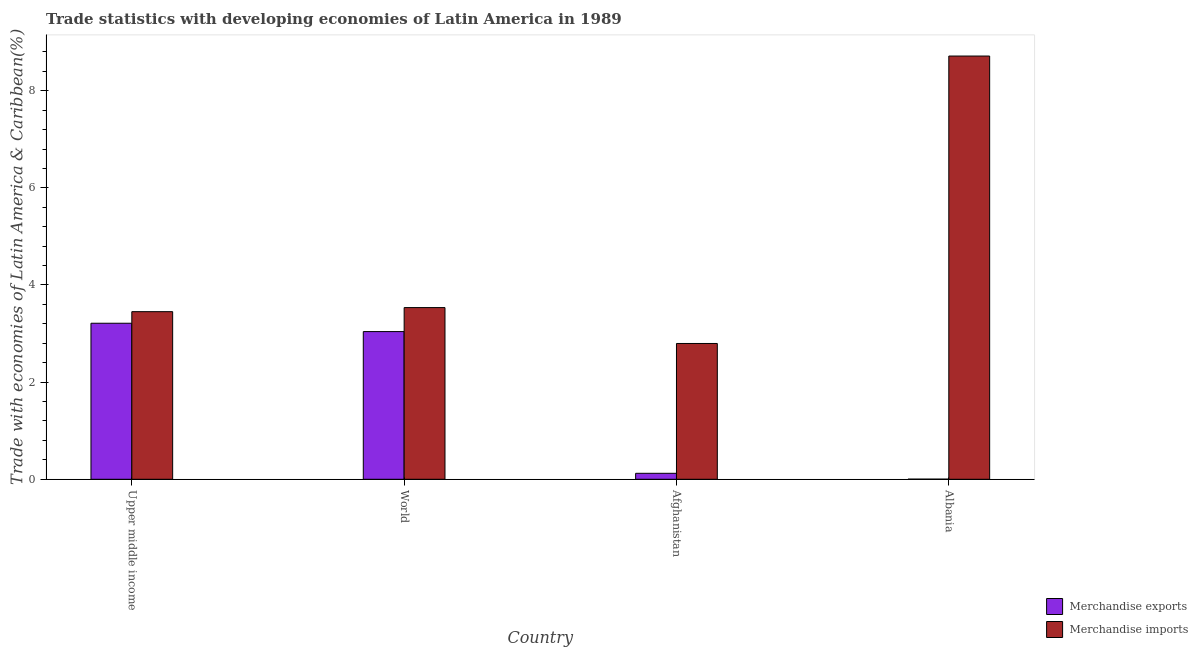How many different coloured bars are there?
Provide a succinct answer. 2. Are the number of bars on each tick of the X-axis equal?
Offer a very short reply. Yes. How many bars are there on the 2nd tick from the left?
Your answer should be compact. 2. What is the label of the 3rd group of bars from the left?
Offer a very short reply. Afghanistan. In how many cases, is the number of bars for a given country not equal to the number of legend labels?
Provide a short and direct response. 0. What is the merchandise exports in World?
Provide a succinct answer. 3.04. Across all countries, what is the maximum merchandise exports?
Your answer should be very brief. 3.21. Across all countries, what is the minimum merchandise imports?
Provide a short and direct response. 2.8. In which country was the merchandise imports maximum?
Your answer should be compact. Albania. In which country was the merchandise imports minimum?
Your answer should be compact. Afghanistan. What is the total merchandise exports in the graph?
Your answer should be compact. 6.38. What is the difference between the merchandise imports in Albania and that in Upper middle income?
Make the answer very short. 5.26. What is the difference between the merchandise imports in Albania and the merchandise exports in World?
Your answer should be compact. 5.67. What is the average merchandise exports per country?
Provide a short and direct response. 1.59. What is the difference between the merchandise imports and merchandise exports in Albania?
Your response must be concise. 8.71. In how many countries, is the merchandise imports greater than 3.6 %?
Keep it short and to the point. 1. What is the ratio of the merchandise imports in Afghanistan to that in World?
Your answer should be very brief. 0.79. What is the difference between the highest and the second highest merchandise exports?
Your answer should be compact. 0.17. What is the difference between the highest and the lowest merchandise imports?
Provide a short and direct response. 5.92. What does the 1st bar from the left in Upper middle income represents?
Offer a terse response. Merchandise exports. What does the 2nd bar from the right in World represents?
Provide a succinct answer. Merchandise exports. Are all the bars in the graph horizontal?
Keep it short and to the point. No. How many countries are there in the graph?
Offer a terse response. 4. Does the graph contain any zero values?
Provide a short and direct response. No. Where does the legend appear in the graph?
Your answer should be very brief. Bottom right. How are the legend labels stacked?
Ensure brevity in your answer.  Vertical. What is the title of the graph?
Offer a terse response. Trade statistics with developing economies of Latin America in 1989. Does "State government" appear as one of the legend labels in the graph?
Ensure brevity in your answer.  No. What is the label or title of the Y-axis?
Your response must be concise. Trade with economies of Latin America & Caribbean(%). What is the Trade with economies of Latin America & Caribbean(%) of Merchandise exports in Upper middle income?
Your response must be concise. 3.21. What is the Trade with economies of Latin America & Caribbean(%) of Merchandise imports in Upper middle income?
Provide a succinct answer. 3.45. What is the Trade with economies of Latin America & Caribbean(%) in Merchandise exports in World?
Give a very brief answer. 3.04. What is the Trade with economies of Latin America & Caribbean(%) in Merchandise imports in World?
Provide a succinct answer. 3.53. What is the Trade with economies of Latin America & Caribbean(%) of Merchandise exports in Afghanistan?
Make the answer very short. 0.12. What is the Trade with economies of Latin America & Caribbean(%) of Merchandise imports in Afghanistan?
Give a very brief answer. 2.8. What is the Trade with economies of Latin America & Caribbean(%) of Merchandise exports in Albania?
Your answer should be very brief. 0. What is the Trade with economies of Latin America & Caribbean(%) of Merchandise imports in Albania?
Provide a succinct answer. 8.71. Across all countries, what is the maximum Trade with economies of Latin America & Caribbean(%) of Merchandise exports?
Your answer should be compact. 3.21. Across all countries, what is the maximum Trade with economies of Latin America & Caribbean(%) in Merchandise imports?
Make the answer very short. 8.71. Across all countries, what is the minimum Trade with economies of Latin America & Caribbean(%) in Merchandise exports?
Ensure brevity in your answer.  0. Across all countries, what is the minimum Trade with economies of Latin America & Caribbean(%) in Merchandise imports?
Your answer should be compact. 2.8. What is the total Trade with economies of Latin America & Caribbean(%) of Merchandise exports in the graph?
Offer a very short reply. 6.38. What is the total Trade with economies of Latin America & Caribbean(%) in Merchandise imports in the graph?
Offer a very short reply. 18.5. What is the difference between the Trade with economies of Latin America & Caribbean(%) of Merchandise exports in Upper middle income and that in World?
Offer a terse response. 0.17. What is the difference between the Trade with economies of Latin America & Caribbean(%) in Merchandise imports in Upper middle income and that in World?
Your response must be concise. -0.08. What is the difference between the Trade with economies of Latin America & Caribbean(%) of Merchandise exports in Upper middle income and that in Afghanistan?
Provide a succinct answer. 3.09. What is the difference between the Trade with economies of Latin America & Caribbean(%) in Merchandise imports in Upper middle income and that in Afghanistan?
Ensure brevity in your answer.  0.66. What is the difference between the Trade with economies of Latin America & Caribbean(%) of Merchandise exports in Upper middle income and that in Albania?
Keep it short and to the point. 3.21. What is the difference between the Trade with economies of Latin America & Caribbean(%) in Merchandise imports in Upper middle income and that in Albania?
Make the answer very short. -5.26. What is the difference between the Trade with economies of Latin America & Caribbean(%) of Merchandise exports in World and that in Afghanistan?
Offer a very short reply. 2.92. What is the difference between the Trade with economies of Latin America & Caribbean(%) of Merchandise imports in World and that in Afghanistan?
Give a very brief answer. 0.74. What is the difference between the Trade with economies of Latin America & Caribbean(%) of Merchandise exports in World and that in Albania?
Your response must be concise. 3.04. What is the difference between the Trade with economies of Latin America & Caribbean(%) of Merchandise imports in World and that in Albania?
Provide a short and direct response. -5.18. What is the difference between the Trade with economies of Latin America & Caribbean(%) of Merchandise exports in Afghanistan and that in Albania?
Provide a succinct answer. 0.12. What is the difference between the Trade with economies of Latin America & Caribbean(%) of Merchandise imports in Afghanistan and that in Albania?
Make the answer very short. -5.92. What is the difference between the Trade with economies of Latin America & Caribbean(%) of Merchandise exports in Upper middle income and the Trade with economies of Latin America & Caribbean(%) of Merchandise imports in World?
Keep it short and to the point. -0.32. What is the difference between the Trade with economies of Latin America & Caribbean(%) in Merchandise exports in Upper middle income and the Trade with economies of Latin America & Caribbean(%) in Merchandise imports in Afghanistan?
Ensure brevity in your answer.  0.42. What is the difference between the Trade with economies of Latin America & Caribbean(%) in Merchandise exports in Upper middle income and the Trade with economies of Latin America & Caribbean(%) in Merchandise imports in Albania?
Your response must be concise. -5.5. What is the difference between the Trade with economies of Latin America & Caribbean(%) of Merchandise exports in World and the Trade with economies of Latin America & Caribbean(%) of Merchandise imports in Afghanistan?
Keep it short and to the point. 0.24. What is the difference between the Trade with economies of Latin America & Caribbean(%) in Merchandise exports in World and the Trade with economies of Latin America & Caribbean(%) in Merchandise imports in Albania?
Give a very brief answer. -5.67. What is the difference between the Trade with economies of Latin America & Caribbean(%) in Merchandise exports in Afghanistan and the Trade with economies of Latin America & Caribbean(%) in Merchandise imports in Albania?
Your answer should be very brief. -8.59. What is the average Trade with economies of Latin America & Caribbean(%) in Merchandise exports per country?
Ensure brevity in your answer.  1.59. What is the average Trade with economies of Latin America & Caribbean(%) in Merchandise imports per country?
Provide a short and direct response. 4.62. What is the difference between the Trade with economies of Latin America & Caribbean(%) of Merchandise exports and Trade with economies of Latin America & Caribbean(%) of Merchandise imports in Upper middle income?
Your answer should be very brief. -0.24. What is the difference between the Trade with economies of Latin America & Caribbean(%) in Merchandise exports and Trade with economies of Latin America & Caribbean(%) in Merchandise imports in World?
Provide a short and direct response. -0.49. What is the difference between the Trade with economies of Latin America & Caribbean(%) of Merchandise exports and Trade with economies of Latin America & Caribbean(%) of Merchandise imports in Afghanistan?
Provide a short and direct response. -2.67. What is the difference between the Trade with economies of Latin America & Caribbean(%) of Merchandise exports and Trade with economies of Latin America & Caribbean(%) of Merchandise imports in Albania?
Provide a succinct answer. -8.71. What is the ratio of the Trade with economies of Latin America & Caribbean(%) in Merchandise exports in Upper middle income to that in World?
Offer a very short reply. 1.06. What is the ratio of the Trade with economies of Latin America & Caribbean(%) of Merchandise imports in Upper middle income to that in World?
Offer a terse response. 0.98. What is the ratio of the Trade with economies of Latin America & Caribbean(%) of Merchandise exports in Upper middle income to that in Afghanistan?
Offer a terse response. 26.12. What is the ratio of the Trade with economies of Latin America & Caribbean(%) of Merchandise imports in Upper middle income to that in Afghanistan?
Your answer should be very brief. 1.23. What is the ratio of the Trade with economies of Latin America & Caribbean(%) in Merchandise exports in Upper middle income to that in Albania?
Offer a very short reply. 1240.08. What is the ratio of the Trade with economies of Latin America & Caribbean(%) of Merchandise imports in Upper middle income to that in Albania?
Your answer should be very brief. 0.4. What is the ratio of the Trade with economies of Latin America & Caribbean(%) in Merchandise exports in World to that in Afghanistan?
Offer a very short reply. 24.72. What is the ratio of the Trade with economies of Latin America & Caribbean(%) of Merchandise imports in World to that in Afghanistan?
Make the answer very short. 1.26. What is the ratio of the Trade with economies of Latin America & Caribbean(%) of Merchandise exports in World to that in Albania?
Provide a succinct answer. 1173.83. What is the ratio of the Trade with economies of Latin America & Caribbean(%) of Merchandise imports in World to that in Albania?
Make the answer very short. 0.41. What is the ratio of the Trade with economies of Latin America & Caribbean(%) in Merchandise exports in Afghanistan to that in Albania?
Ensure brevity in your answer.  47.48. What is the ratio of the Trade with economies of Latin America & Caribbean(%) of Merchandise imports in Afghanistan to that in Albania?
Offer a terse response. 0.32. What is the difference between the highest and the second highest Trade with economies of Latin America & Caribbean(%) of Merchandise exports?
Your response must be concise. 0.17. What is the difference between the highest and the second highest Trade with economies of Latin America & Caribbean(%) in Merchandise imports?
Your answer should be very brief. 5.18. What is the difference between the highest and the lowest Trade with economies of Latin America & Caribbean(%) of Merchandise exports?
Offer a terse response. 3.21. What is the difference between the highest and the lowest Trade with economies of Latin America & Caribbean(%) in Merchandise imports?
Give a very brief answer. 5.92. 